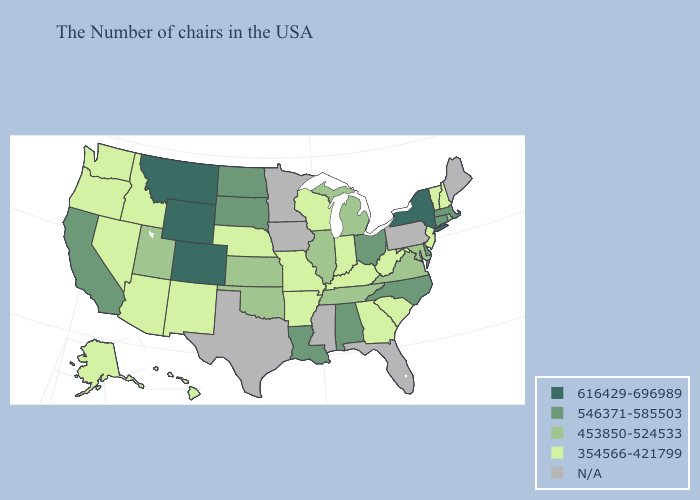Among the states that border Kansas , does Oklahoma have the lowest value?
Concise answer only. No. What is the highest value in states that border Kansas?
Short answer required. 616429-696989. What is the highest value in states that border Missouri?
Answer briefly. 453850-524533. What is the value of Nebraska?
Short answer required. 354566-421799. What is the value of Wyoming?
Write a very short answer. 616429-696989. Name the states that have a value in the range 546371-585503?
Give a very brief answer. Massachusetts, Connecticut, Delaware, North Carolina, Ohio, Alabama, Louisiana, South Dakota, North Dakota, California. Name the states that have a value in the range 453850-524533?
Give a very brief answer. Rhode Island, Maryland, Virginia, Michigan, Tennessee, Illinois, Kansas, Oklahoma, Utah. Does Wisconsin have the lowest value in the USA?
Short answer required. Yes. Which states have the highest value in the USA?
Quick response, please. New York, Wyoming, Colorado, Montana. Does Wyoming have the highest value in the USA?
Write a very short answer. Yes. Name the states that have a value in the range 546371-585503?
Concise answer only. Massachusetts, Connecticut, Delaware, North Carolina, Ohio, Alabama, Louisiana, South Dakota, North Dakota, California. What is the value of Idaho?
Keep it brief. 354566-421799. Name the states that have a value in the range 453850-524533?
Write a very short answer. Rhode Island, Maryland, Virginia, Michigan, Tennessee, Illinois, Kansas, Oklahoma, Utah. Does the first symbol in the legend represent the smallest category?
Give a very brief answer. No. 